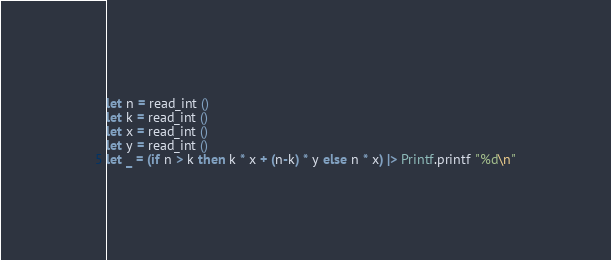Convert code to text. <code><loc_0><loc_0><loc_500><loc_500><_OCaml_>let n = read_int ()
let k = read_int ()
let x = read_int ()
let y = read_int ()
let _ = (if n > k then k * x + (n-k) * y else n * x) |> Printf.printf "%d\n"</code> 